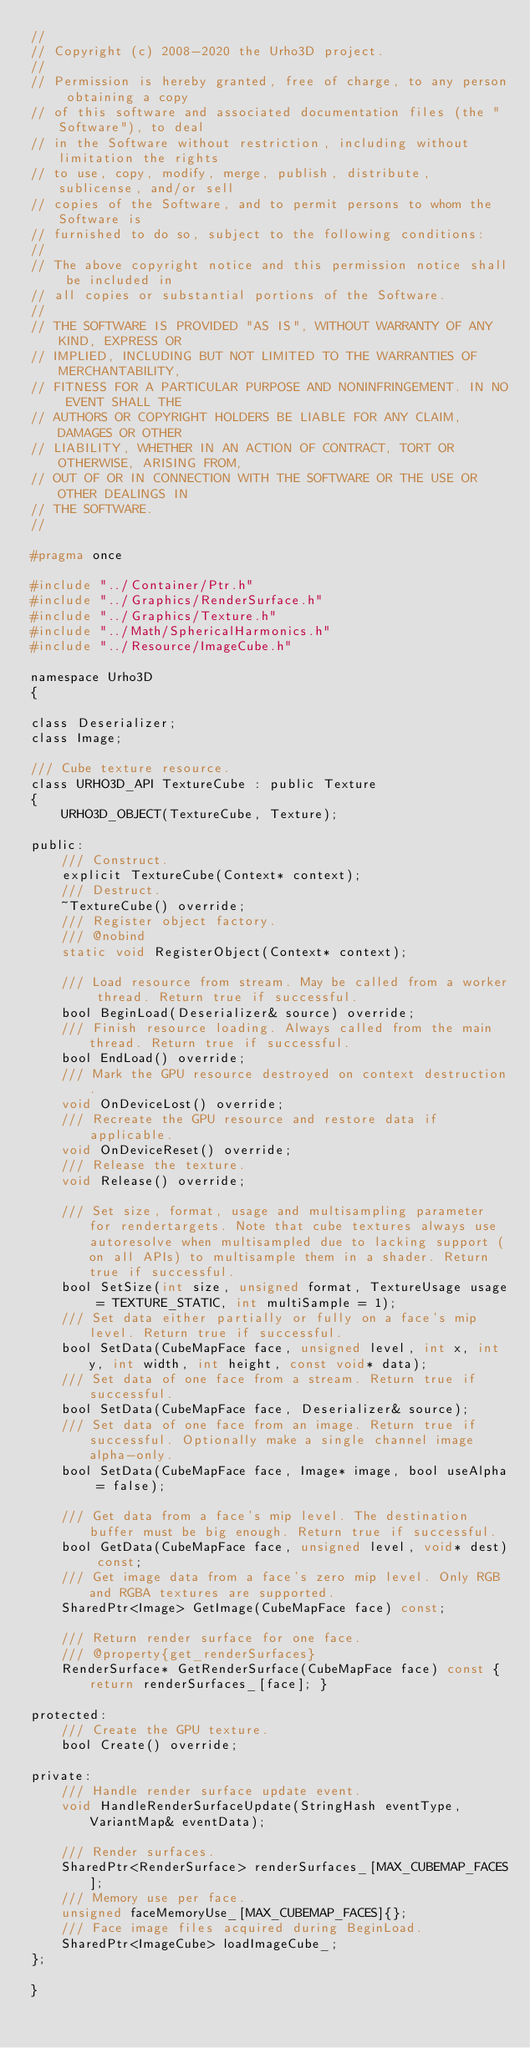Convert code to text. <code><loc_0><loc_0><loc_500><loc_500><_C_>//
// Copyright (c) 2008-2020 the Urho3D project.
//
// Permission is hereby granted, free of charge, to any person obtaining a copy
// of this software and associated documentation files (the "Software"), to deal
// in the Software without restriction, including without limitation the rights
// to use, copy, modify, merge, publish, distribute, sublicense, and/or sell
// copies of the Software, and to permit persons to whom the Software is
// furnished to do so, subject to the following conditions:
//
// The above copyright notice and this permission notice shall be included in
// all copies or substantial portions of the Software.
//
// THE SOFTWARE IS PROVIDED "AS IS", WITHOUT WARRANTY OF ANY KIND, EXPRESS OR
// IMPLIED, INCLUDING BUT NOT LIMITED TO THE WARRANTIES OF MERCHANTABILITY,
// FITNESS FOR A PARTICULAR PURPOSE AND NONINFRINGEMENT. IN NO EVENT SHALL THE
// AUTHORS OR COPYRIGHT HOLDERS BE LIABLE FOR ANY CLAIM, DAMAGES OR OTHER
// LIABILITY, WHETHER IN AN ACTION OF CONTRACT, TORT OR OTHERWISE, ARISING FROM,
// OUT OF OR IN CONNECTION WITH THE SOFTWARE OR THE USE OR OTHER DEALINGS IN
// THE SOFTWARE.
//

#pragma once

#include "../Container/Ptr.h"
#include "../Graphics/RenderSurface.h"
#include "../Graphics/Texture.h"
#include "../Math/SphericalHarmonics.h"
#include "../Resource/ImageCube.h"

namespace Urho3D
{

class Deserializer;
class Image;

/// Cube texture resource.
class URHO3D_API TextureCube : public Texture
{
    URHO3D_OBJECT(TextureCube, Texture);

public:
    /// Construct.
    explicit TextureCube(Context* context);
    /// Destruct.
    ~TextureCube() override;
    /// Register object factory.
    /// @nobind
    static void RegisterObject(Context* context);

    /// Load resource from stream. May be called from a worker thread. Return true if successful.
    bool BeginLoad(Deserializer& source) override;
    /// Finish resource loading. Always called from the main thread. Return true if successful.
    bool EndLoad() override;
    /// Mark the GPU resource destroyed on context destruction.
    void OnDeviceLost() override;
    /// Recreate the GPU resource and restore data if applicable.
    void OnDeviceReset() override;
    /// Release the texture.
    void Release() override;

    /// Set size, format, usage and multisampling parameter for rendertargets. Note that cube textures always use autoresolve when multisampled due to lacking support (on all APIs) to multisample them in a shader. Return true if successful.
    bool SetSize(int size, unsigned format, TextureUsage usage = TEXTURE_STATIC, int multiSample = 1);
    /// Set data either partially or fully on a face's mip level. Return true if successful.
    bool SetData(CubeMapFace face, unsigned level, int x, int y, int width, int height, const void* data);
    /// Set data of one face from a stream. Return true if successful.
    bool SetData(CubeMapFace face, Deserializer& source);
    /// Set data of one face from an image. Return true if successful. Optionally make a single channel image alpha-only.
    bool SetData(CubeMapFace face, Image* image, bool useAlpha = false);

    /// Get data from a face's mip level. The destination buffer must be big enough. Return true if successful.
    bool GetData(CubeMapFace face, unsigned level, void* dest) const;
    /// Get image data from a face's zero mip level. Only RGB and RGBA textures are supported.
    SharedPtr<Image> GetImage(CubeMapFace face) const;

    /// Return render surface for one face.
    /// @property{get_renderSurfaces}
    RenderSurface* GetRenderSurface(CubeMapFace face) const { return renderSurfaces_[face]; }

protected:
    /// Create the GPU texture.
    bool Create() override;

private:
    /// Handle render surface update event.
    void HandleRenderSurfaceUpdate(StringHash eventType, VariantMap& eventData);

    /// Render surfaces.
    SharedPtr<RenderSurface> renderSurfaces_[MAX_CUBEMAP_FACES];
    /// Memory use per face.
    unsigned faceMemoryUse_[MAX_CUBEMAP_FACES]{};
    /// Face image files acquired during BeginLoad.
    SharedPtr<ImageCube> loadImageCube_;
};

}
</code> 